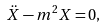Convert formula to latex. <formula><loc_0><loc_0><loc_500><loc_500>\ddot { X } - m ^ { 2 } X = 0 ,</formula> 